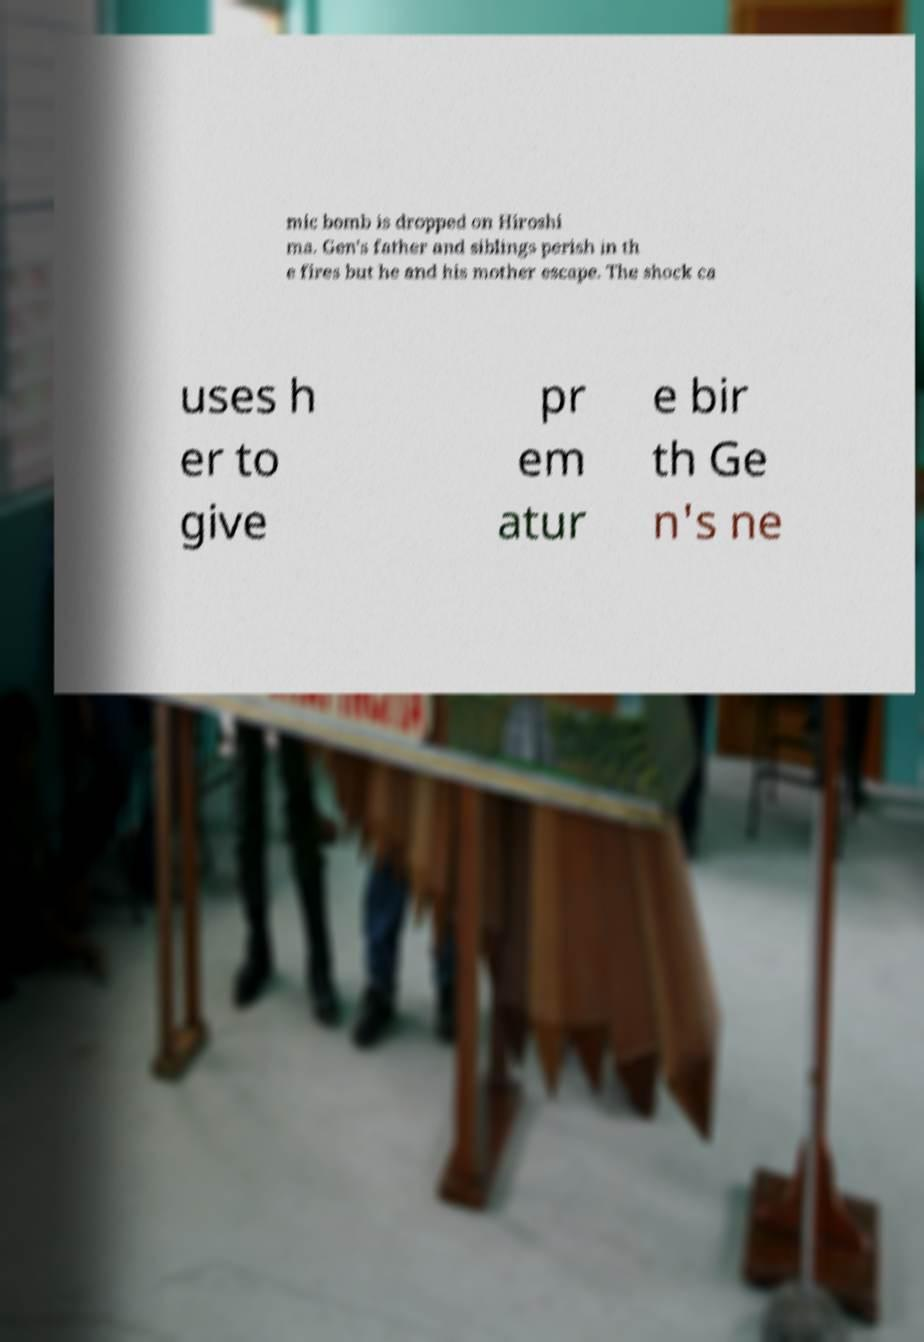What messages or text are displayed in this image? I need them in a readable, typed format. mic bomb is dropped on Hiroshi ma. Gen's father and siblings perish in th e fires but he and his mother escape. The shock ca uses h er to give pr em atur e bir th Ge n's ne 